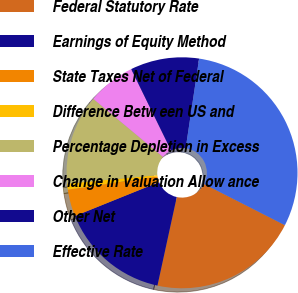Convert chart to OTSL. <chart><loc_0><loc_0><loc_500><loc_500><pie_chart><fcel>Federal Statutory Rate<fcel>Earnings of Equity Method<fcel>State Taxes Net of Federal<fcel>Difference Betw een US and<fcel>Percentage Depletion in Excess<fcel>Change in Valuation Allow ance<fcel>Other Net<fcel>Effective Rate<nl><fcel>20.92%<fcel>15.48%<fcel>3.77%<fcel>0.84%<fcel>12.55%<fcel>6.69%<fcel>9.62%<fcel>30.13%<nl></chart> 